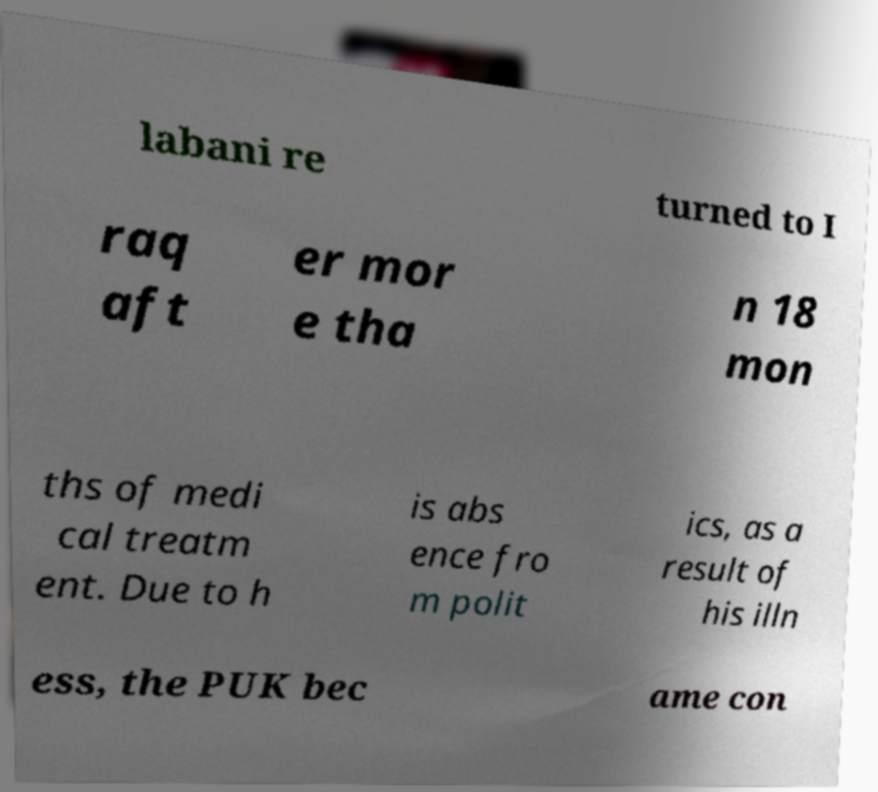There's text embedded in this image that I need extracted. Can you transcribe it verbatim? labani re turned to I raq aft er mor e tha n 18 mon ths of medi cal treatm ent. Due to h is abs ence fro m polit ics, as a result of his illn ess, the PUK bec ame con 